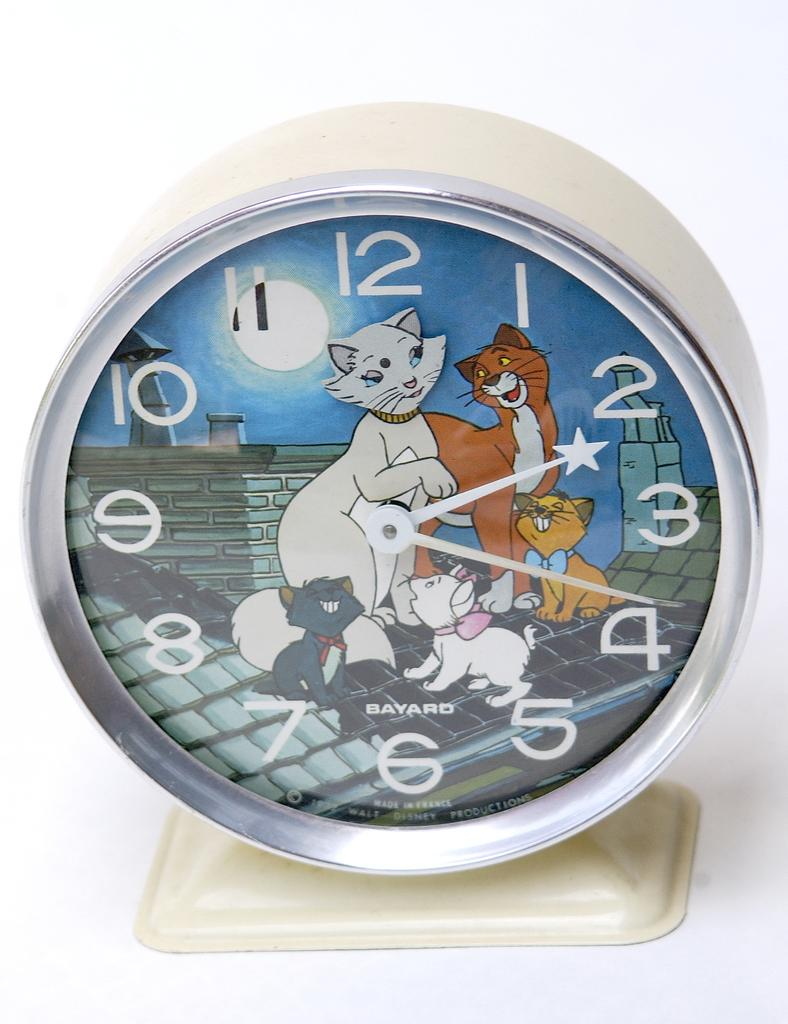What object in the picture indicates the time? There is a clock in the picture that indicates the time. What feature does the clock have to display the time? The clock has numbers on it. What additional design element is present on the clock? There are cartoon characters on the clock. What is the color of the background in the image? The background of the image is white. Can you see any popcorn being served at the airport in the morning in the image? There is no reference to an airport, popcorn, or morning in the image; it features a clock with numbers and cartoon characters against a white background. 